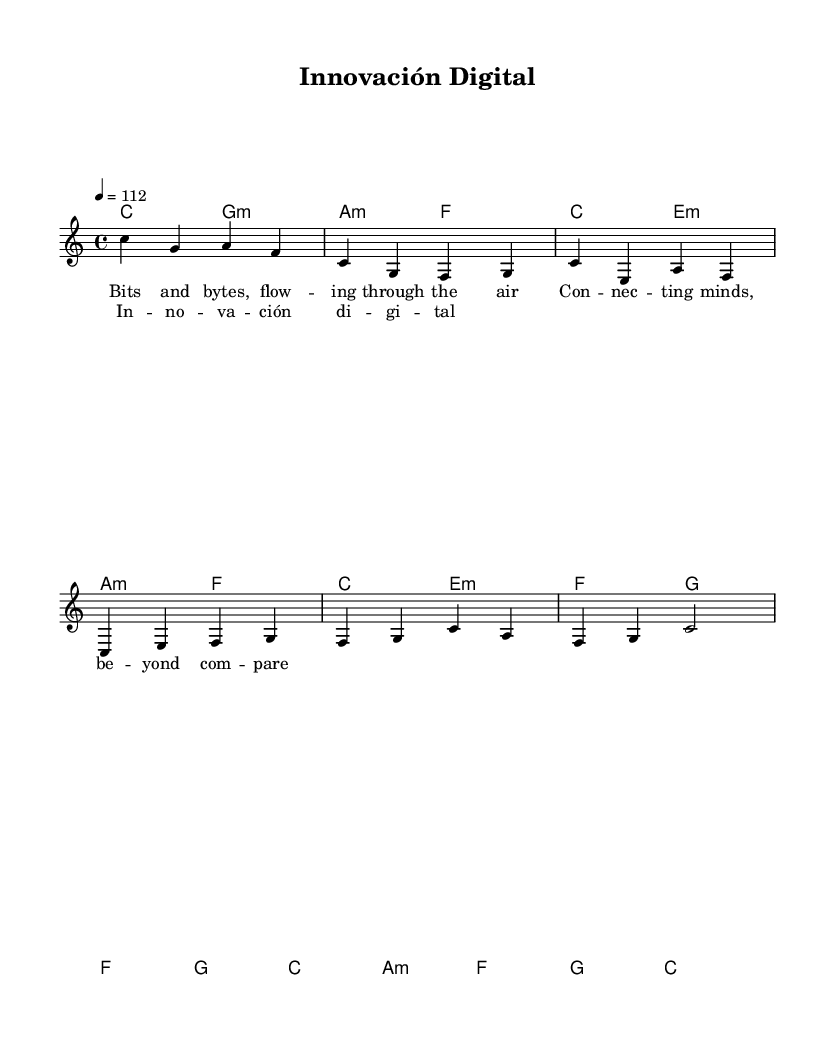What is the key signature of this music? The key signature is indicated in the global section and shows no sharps or flats, which corresponds to C major.
Answer: C major What is the time signature of this music? The time signature is found in the global section, where it is explicitly stated as 4/4, meaning there are four beats per measure and a quarter note receives one beat.
Answer: 4/4 What is the tempo marking for this piece? The tempo is specified in the global section as "4 = 112," indicating a tempo of 112 beats per minute with the quarter note as the beat.
Answer: 112 How many measures are in the verse? The verse contains two sections, each with four measures, making a total of eight measures. This can be determined by counting the measures in the melody and harmonies from the code.
Answer: 8 What is the lyrical theme of the chorus? The lyrics of the chorus focus on technological innovation, as indicated by the text "Innovación digital" within the context of the song about technological progress.
Answer: Innovación digital Which chords are used in the chorus? The chorus consists of the following chords: f, g, c, a minor, showing the harmonic progression made throughout this section and contributing to the song's overall feel.
Answer: f, g, c, a minor What type of musical form is present in this piece? The piece demonstrates a simple verse-chorus structure, which is characteristic of many Latin pop songs, by alternating between verses and the repeating chorus.
Answer: Verse-Chorus 